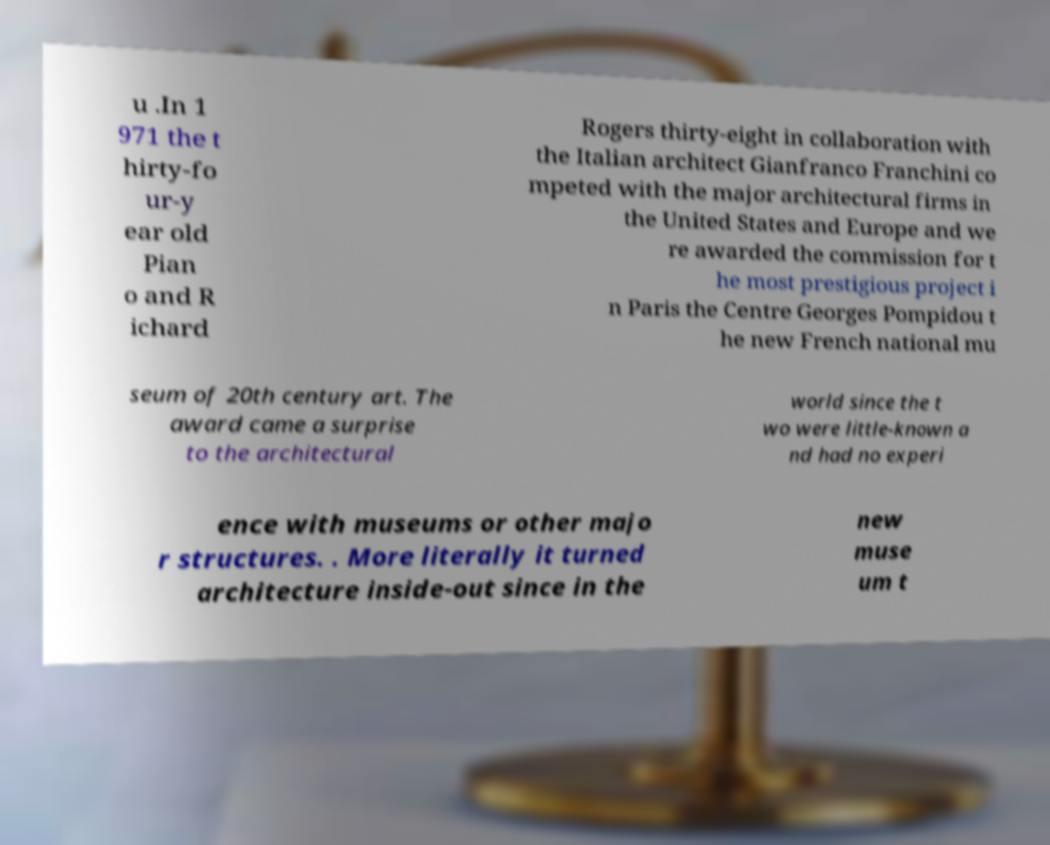For documentation purposes, I need the text within this image transcribed. Could you provide that? u .In 1 971 the t hirty-fo ur-y ear old Pian o and R ichard Rogers thirty-eight in collaboration with the Italian architect Gianfranco Franchini co mpeted with the major architectural firms in the United States and Europe and we re awarded the commission for t he most prestigious project i n Paris the Centre Georges Pompidou t he new French national mu seum of 20th century art. The award came a surprise to the architectural world since the t wo were little-known a nd had no experi ence with museums or other majo r structures. . More literally it turned architecture inside-out since in the new muse um t 